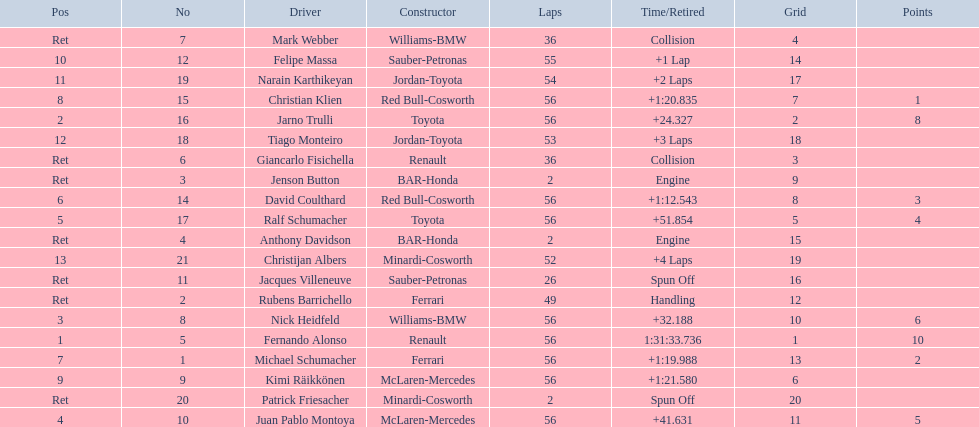How many drivers were retired before the race could end? 7. 